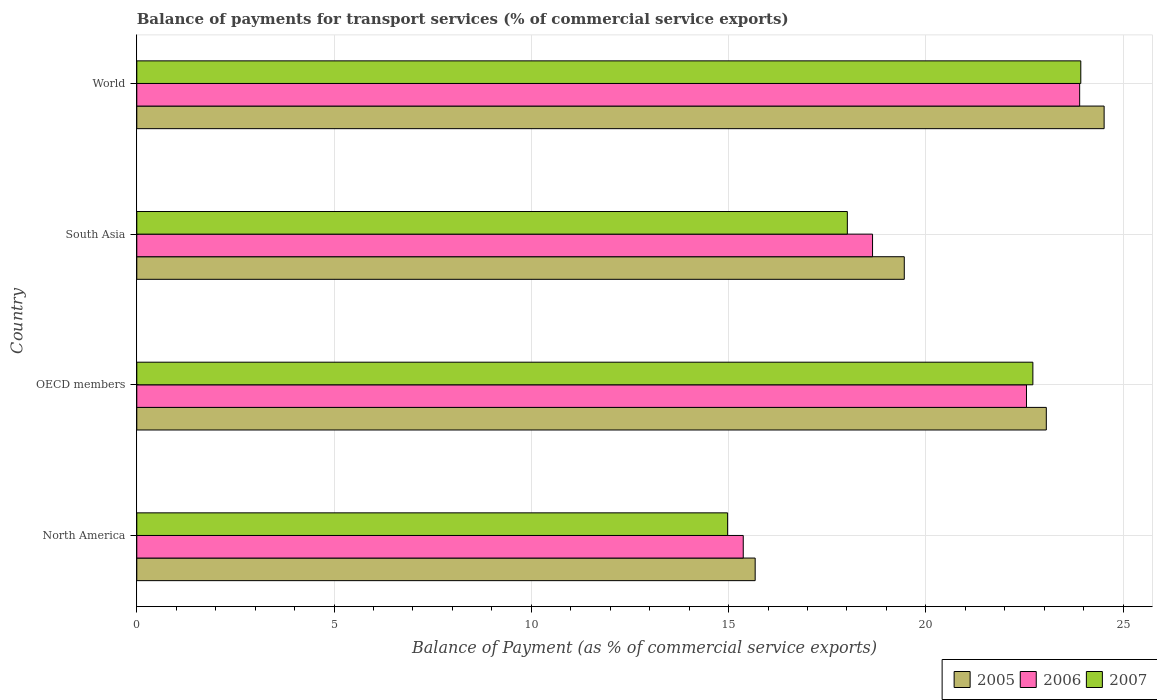Are the number of bars on each tick of the Y-axis equal?
Your response must be concise. Yes. How many bars are there on the 1st tick from the top?
Offer a terse response. 3. What is the label of the 4th group of bars from the top?
Your answer should be very brief. North America. What is the balance of payments for transport services in 2005 in South Asia?
Give a very brief answer. 19.45. Across all countries, what is the maximum balance of payments for transport services in 2005?
Offer a very short reply. 24.52. Across all countries, what is the minimum balance of payments for transport services in 2005?
Give a very brief answer. 15.67. What is the total balance of payments for transport services in 2006 in the graph?
Your answer should be compact. 80.47. What is the difference between the balance of payments for transport services in 2007 in North America and that in OECD members?
Offer a very short reply. -7.74. What is the difference between the balance of payments for transport services in 2007 in World and the balance of payments for transport services in 2005 in OECD members?
Your response must be concise. 0.87. What is the average balance of payments for transport services in 2007 per country?
Make the answer very short. 19.91. What is the difference between the balance of payments for transport services in 2006 and balance of payments for transport services in 2007 in World?
Keep it short and to the point. -0.03. In how many countries, is the balance of payments for transport services in 2006 greater than 23 %?
Ensure brevity in your answer.  1. What is the ratio of the balance of payments for transport services in 2007 in North America to that in World?
Make the answer very short. 0.63. What is the difference between the highest and the second highest balance of payments for transport services in 2006?
Offer a terse response. 1.35. What is the difference between the highest and the lowest balance of payments for transport services in 2006?
Give a very brief answer. 8.53. Is the sum of the balance of payments for transport services in 2005 in North America and OECD members greater than the maximum balance of payments for transport services in 2007 across all countries?
Your answer should be very brief. Yes. What does the 1st bar from the bottom in OECD members represents?
Offer a very short reply. 2005. Are all the bars in the graph horizontal?
Your answer should be compact. Yes. How many countries are there in the graph?
Make the answer very short. 4. Does the graph contain any zero values?
Ensure brevity in your answer.  No. Does the graph contain grids?
Offer a terse response. Yes. Where does the legend appear in the graph?
Offer a terse response. Bottom right. What is the title of the graph?
Ensure brevity in your answer.  Balance of payments for transport services (% of commercial service exports). What is the label or title of the X-axis?
Offer a very short reply. Balance of Payment (as % of commercial service exports). What is the label or title of the Y-axis?
Provide a succinct answer. Country. What is the Balance of Payment (as % of commercial service exports) of 2005 in North America?
Ensure brevity in your answer.  15.67. What is the Balance of Payment (as % of commercial service exports) of 2006 in North America?
Offer a very short reply. 15.37. What is the Balance of Payment (as % of commercial service exports) of 2007 in North America?
Your answer should be very brief. 14.97. What is the Balance of Payment (as % of commercial service exports) in 2005 in OECD members?
Offer a very short reply. 23.05. What is the Balance of Payment (as % of commercial service exports) in 2006 in OECD members?
Ensure brevity in your answer.  22.55. What is the Balance of Payment (as % of commercial service exports) in 2007 in OECD members?
Your response must be concise. 22.71. What is the Balance of Payment (as % of commercial service exports) of 2005 in South Asia?
Provide a short and direct response. 19.45. What is the Balance of Payment (as % of commercial service exports) of 2006 in South Asia?
Your answer should be compact. 18.65. What is the Balance of Payment (as % of commercial service exports) in 2007 in South Asia?
Provide a short and direct response. 18.01. What is the Balance of Payment (as % of commercial service exports) of 2005 in World?
Keep it short and to the point. 24.52. What is the Balance of Payment (as % of commercial service exports) of 2006 in World?
Offer a very short reply. 23.9. What is the Balance of Payment (as % of commercial service exports) of 2007 in World?
Your answer should be compact. 23.93. Across all countries, what is the maximum Balance of Payment (as % of commercial service exports) of 2005?
Make the answer very short. 24.52. Across all countries, what is the maximum Balance of Payment (as % of commercial service exports) of 2006?
Give a very brief answer. 23.9. Across all countries, what is the maximum Balance of Payment (as % of commercial service exports) of 2007?
Provide a succinct answer. 23.93. Across all countries, what is the minimum Balance of Payment (as % of commercial service exports) of 2005?
Your answer should be very brief. 15.67. Across all countries, what is the minimum Balance of Payment (as % of commercial service exports) of 2006?
Provide a succinct answer. 15.37. Across all countries, what is the minimum Balance of Payment (as % of commercial service exports) in 2007?
Provide a succinct answer. 14.97. What is the total Balance of Payment (as % of commercial service exports) in 2005 in the graph?
Your answer should be very brief. 82.69. What is the total Balance of Payment (as % of commercial service exports) in 2006 in the graph?
Make the answer very short. 80.47. What is the total Balance of Payment (as % of commercial service exports) in 2007 in the graph?
Provide a succinct answer. 79.62. What is the difference between the Balance of Payment (as % of commercial service exports) in 2005 in North America and that in OECD members?
Provide a succinct answer. -7.38. What is the difference between the Balance of Payment (as % of commercial service exports) in 2006 in North America and that in OECD members?
Make the answer very short. -7.18. What is the difference between the Balance of Payment (as % of commercial service exports) in 2007 in North America and that in OECD members?
Provide a short and direct response. -7.74. What is the difference between the Balance of Payment (as % of commercial service exports) in 2005 in North America and that in South Asia?
Your answer should be very brief. -3.78. What is the difference between the Balance of Payment (as % of commercial service exports) in 2006 in North America and that in South Asia?
Offer a terse response. -3.28. What is the difference between the Balance of Payment (as % of commercial service exports) of 2007 in North America and that in South Asia?
Provide a succinct answer. -3.03. What is the difference between the Balance of Payment (as % of commercial service exports) of 2005 in North America and that in World?
Offer a very short reply. -8.84. What is the difference between the Balance of Payment (as % of commercial service exports) of 2006 in North America and that in World?
Provide a succinct answer. -8.53. What is the difference between the Balance of Payment (as % of commercial service exports) in 2007 in North America and that in World?
Your answer should be compact. -8.95. What is the difference between the Balance of Payment (as % of commercial service exports) in 2005 in OECD members and that in South Asia?
Offer a very short reply. 3.6. What is the difference between the Balance of Payment (as % of commercial service exports) in 2006 in OECD members and that in South Asia?
Make the answer very short. 3.9. What is the difference between the Balance of Payment (as % of commercial service exports) in 2007 in OECD members and that in South Asia?
Offer a very short reply. 4.7. What is the difference between the Balance of Payment (as % of commercial service exports) in 2005 in OECD members and that in World?
Provide a short and direct response. -1.47. What is the difference between the Balance of Payment (as % of commercial service exports) of 2006 in OECD members and that in World?
Ensure brevity in your answer.  -1.35. What is the difference between the Balance of Payment (as % of commercial service exports) of 2007 in OECD members and that in World?
Provide a succinct answer. -1.21. What is the difference between the Balance of Payment (as % of commercial service exports) of 2005 in South Asia and that in World?
Offer a terse response. -5.07. What is the difference between the Balance of Payment (as % of commercial service exports) in 2006 in South Asia and that in World?
Provide a succinct answer. -5.25. What is the difference between the Balance of Payment (as % of commercial service exports) of 2007 in South Asia and that in World?
Offer a very short reply. -5.92. What is the difference between the Balance of Payment (as % of commercial service exports) in 2005 in North America and the Balance of Payment (as % of commercial service exports) in 2006 in OECD members?
Provide a succinct answer. -6.88. What is the difference between the Balance of Payment (as % of commercial service exports) in 2005 in North America and the Balance of Payment (as % of commercial service exports) in 2007 in OECD members?
Provide a short and direct response. -7.04. What is the difference between the Balance of Payment (as % of commercial service exports) in 2006 in North America and the Balance of Payment (as % of commercial service exports) in 2007 in OECD members?
Keep it short and to the point. -7.34. What is the difference between the Balance of Payment (as % of commercial service exports) in 2005 in North America and the Balance of Payment (as % of commercial service exports) in 2006 in South Asia?
Your answer should be compact. -2.98. What is the difference between the Balance of Payment (as % of commercial service exports) in 2005 in North America and the Balance of Payment (as % of commercial service exports) in 2007 in South Asia?
Provide a short and direct response. -2.34. What is the difference between the Balance of Payment (as % of commercial service exports) of 2006 in North America and the Balance of Payment (as % of commercial service exports) of 2007 in South Asia?
Offer a terse response. -2.64. What is the difference between the Balance of Payment (as % of commercial service exports) in 2005 in North America and the Balance of Payment (as % of commercial service exports) in 2006 in World?
Give a very brief answer. -8.22. What is the difference between the Balance of Payment (as % of commercial service exports) in 2005 in North America and the Balance of Payment (as % of commercial service exports) in 2007 in World?
Offer a terse response. -8.25. What is the difference between the Balance of Payment (as % of commercial service exports) of 2006 in North America and the Balance of Payment (as % of commercial service exports) of 2007 in World?
Ensure brevity in your answer.  -8.56. What is the difference between the Balance of Payment (as % of commercial service exports) of 2005 in OECD members and the Balance of Payment (as % of commercial service exports) of 2006 in South Asia?
Give a very brief answer. 4.4. What is the difference between the Balance of Payment (as % of commercial service exports) of 2005 in OECD members and the Balance of Payment (as % of commercial service exports) of 2007 in South Asia?
Give a very brief answer. 5.04. What is the difference between the Balance of Payment (as % of commercial service exports) in 2006 in OECD members and the Balance of Payment (as % of commercial service exports) in 2007 in South Asia?
Provide a succinct answer. 4.54. What is the difference between the Balance of Payment (as % of commercial service exports) of 2005 in OECD members and the Balance of Payment (as % of commercial service exports) of 2006 in World?
Give a very brief answer. -0.85. What is the difference between the Balance of Payment (as % of commercial service exports) in 2005 in OECD members and the Balance of Payment (as % of commercial service exports) in 2007 in World?
Ensure brevity in your answer.  -0.87. What is the difference between the Balance of Payment (as % of commercial service exports) in 2006 in OECD members and the Balance of Payment (as % of commercial service exports) in 2007 in World?
Ensure brevity in your answer.  -1.38. What is the difference between the Balance of Payment (as % of commercial service exports) of 2005 in South Asia and the Balance of Payment (as % of commercial service exports) of 2006 in World?
Provide a short and direct response. -4.45. What is the difference between the Balance of Payment (as % of commercial service exports) of 2005 in South Asia and the Balance of Payment (as % of commercial service exports) of 2007 in World?
Offer a terse response. -4.47. What is the difference between the Balance of Payment (as % of commercial service exports) in 2006 in South Asia and the Balance of Payment (as % of commercial service exports) in 2007 in World?
Your answer should be very brief. -5.28. What is the average Balance of Payment (as % of commercial service exports) of 2005 per country?
Offer a terse response. 20.67. What is the average Balance of Payment (as % of commercial service exports) in 2006 per country?
Your answer should be compact. 20.12. What is the average Balance of Payment (as % of commercial service exports) of 2007 per country?
Provide a succinct answer. 19.91. What is the difference between the Balance of Payment (as % of commercial service exports) in 2005 and Balance of Payment (as % of commercial service exports) in 2006 in North America?
Provide a short and direct response. 0.3. What is the difference between the Balance of Payment (as % of commercial service exports) of 2005 and Balance of Payment (as % of commercial service exports) of 2007 in North America?
Give a very brief answer. 0.7. What is the difference between the Balance of Payment (as % of commercial service exports) of 2006 and Balance of Payment (as % of commercial service exports) of 2007 in North America?
Provide a short and direct response. 0.4. What is the difference between the Balance of Payment (as % of commercial service exports) in 2005 and Balance of Payment (as % of commercial service exports) in 2006 in OECD members?
Offer a very short reply. 0.5. What is the difference between the Balance of Payment (as % of commercial service exports) in 2005 and Balance of Payment (as % of commercial service exports) in 2007 in OECD members?
Offer a terse response. 0.34. What is the difference between the Balance of Payment (as % of commercial service exports) in 2006 and Balance of Payment (as % of commercial service exports) in 2007 in OECD members?
Ensure brevity in your answer.  -0.16. What is the difference between the Balance of Payment (as % of commercial service exports) of 2005 and Balance of Payment (as % of commercial service exports) of 2006 in South Asia?
Offer a very short reply. 0.8. What is the difference between the Balance of Payment (as % of commercial service exports) of 2005 and Balance of Payment (as % of commercial service exports) of 2007 in South Asia?
Your response must be concise. 1.44. What is the difference between the Balance of Payment (as % of commercial service exports) of 2006 and Balance of Payment (as % of commercial service exports) of 2007 in South Asia?
Offer a very short reply. 0.64. What is the difference between the Balance of Payment (as % of commercial service exports) in 2005 and Balance of Payment (as % of commercial service exports) in 2006 in World?
Keep it short and to the point. 0.62. What is the difference between the Balance of Payment (as % of commercial service exports) in 2005 and Balance of Payment (as % of commercial service exports) in 2007 in World?
Your answer should be compact. 0.59. What is the difference between the Balance of Payment (as % of commercial service exports) of 2006 and Balance of Payment (as % of commercial service exports) of 2007 in World?
Keep it short and to the point. -0.03. What is the ratio of the Balance of Payment (as % of commercial service exports) of 2005 in North America to that in OECD members?
Your response must be concise. 0.68. What is the ratio of the Balance of Payment (as % of commercial service exports) of 2006 in North America to that in OECD members?
Your response must be concise. 0.68. What is the ratio of the Balance of Payment (as % of commercial service exports) in 2007 in North America to that in OECD members?
Keep it short and to the point. 0.66. What is the ratio of the Balance of Payment (as % of commercial service exports) in 2005 in North America to that in South Asia?
Keep it short and to the point. 0.81. What is the ratio of the Balance of Payment (as % of commercial service exports) in 2006 in North America to that in South Asia?
Keep it short and to the point. 0.82. What is the ratio of the Balance of Payment (as % of commercial service exports) in 2007 in North America to that in South Asia?
Offer a very short reply. 0.83. What is the ratio of the Balance of Payment (as % of commercial service exports) of 2005 in North America to that in World?
Provide a succinct answer. 0.64. What is the ratio of the Balance of Payment (as % of commercial service exports) in 2006 in North America to that in World?
Provide a succinct answer. 0.64. What is the ratio of the Balance of Payment (as % of commercial service exports) in 2007 in North America to that in World?
Offer a very short reply. 0.63. What is the ratio of the Balance of Payment (as % of commercial service exports) in 2005 in OECD members to that in South Asia?
Ensure brevity in your answer.  1.19. What is the ratio of the Balance of Payment (as % of commercial service exports) in 2006 in OECD members to that in South Asia?
Provide a succinct answer. 1.21. What is the ratio of the Balance of Payment (as % of commercial service exports) in 2007 in OECD members to that in South Asia?
Your response must be concise. 1.26. What is the ratio of the Balance of Payment (as % of commercial service exports) in 2005 in OECD members to that in World?
Make the answer very short. 0.94. What is the ratio of the Balance of Payment (as % of commercial service exports) in 2006 in OECD members to that in World?
Offer a terse response. 0.94. What is the ratio of the Balance of Payment (as % of commercial service exports) in 2007 in OECD members to that in World?
Provide a short and direct response. 0.95. What is the ratio of the Balance of Payment (as % of commercial service exports) in 2005 in South Asia to that in World?
Give a very brief answer. 0.79. What is the ratio of the Balance of Payment (as % of commercial service exports) of 2006 in South Asia to that in World?
Make the answer very short. 0.78. What is the ratio of the Balance of Payment (as % of commercial service exports) in 2007 in South Asia to that in World?
Give a very brief answer. 0.75. What is the difference between the highest and the second highest Balance of Payment (as % of commercial service exports) of 2005?
Provide a succinct answer. 1.47. What is the difference between the highest and the second highest Balance of Payment (as % of commercial service exports) in 2006?
Make the answer very short. 1.35. What is the difference between the highest and the second highest Balance of Payment (as % of commercial service exports) in 2007?
Keep it short and to the point. 1.21. What is the difference between the highest and the lowest Balance of Payment (as % of commercial service exports) of 2005?
Your answer should be compact. 8.84. What is the difference between the highest and the lowest Balance of Payment (as % of commercial service exports) in 2006?
Offer a very short reply. 8.53. What is the difference between the highest and the lowest Balance of Payment (as % of commercial service exports) in 2007?
Offer a terse response. 8.95. 